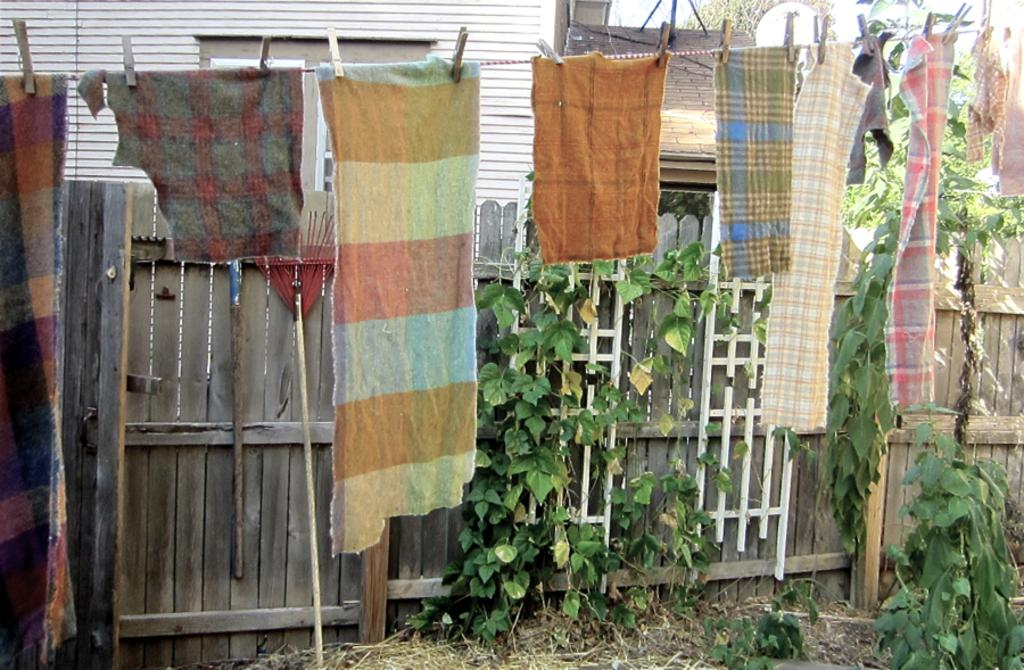What type of structure is visible in the image? There is a house in the image. What is being hung on the rope in the image? Clothes are hung on a rope in the image. How are the clothes attached to the rope? The clothes are clipped to the rope. What type of vegetation is present in the image? Plants are present in the image. What type of plant is visible in the image? Creepers are visible in the image. What type of poison is being used to water the plants in the image? There is no indication of any poison being used in the image; the plants appear to be watered naturally. 